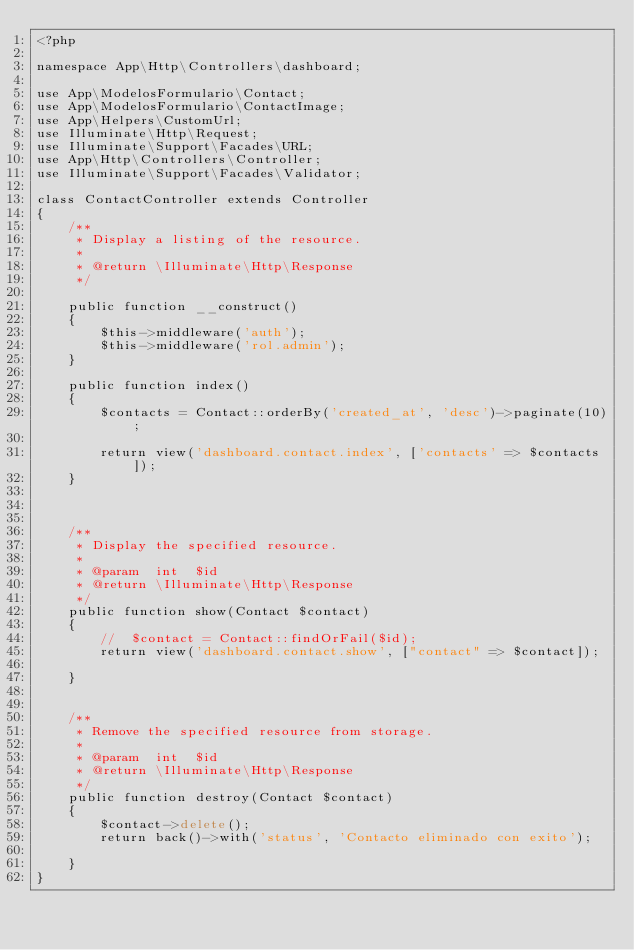<code> <loc_0><loc_0><loc_500><loc_500><_PHP_><?php

namespace App\Http\Controllers\dashboard;

use App\ModelosFormulario\Contact;
use App\ModelosFormulario\ContactImage;
use App\Helpers\CustomUrl;
use Illuminate\Http\Request;
use Illuminate\Support\Facades\URL;
use App\Http\Controllers\Controller;
use Illuminate\Support\Facades\Validator;
 
class ContactController extends Controller
{
    /**
     * Display a listing of the resource.
     *
     * @return \Illuminate\Http\Response
     */

    public function __construct()
    {
        $this->middleware('auth');
        $this->middleware('rol.admin');
    }

    public function index()
    {
        $contacts = Contact::orderBy('created_at', 'desc')->paginate(10);

        return view('dashboard.contact.index', ['contacts' => $contacts]);
    }



    /**
     * Display the specified resource.
     *
     * @param  int  $id
     * @return \Illuminate\Http\Response
     */
    public function show(Contact $contact)
    {
        //  $contact = Contact::findOrFail($id);
        return view('dashboard.contact.show', ["contact" => $contact]);

    }


    /**
     * Remove the specified resource from storage.
     *
     * @param  int  $id
     * @return \Illuminate\Http\Response
     */
    public function destroy(Contact $contact)
    {
        $contact->delete();
        return back()->with('status', 'Contacto eliminado con exito');

    }
}
</code> 